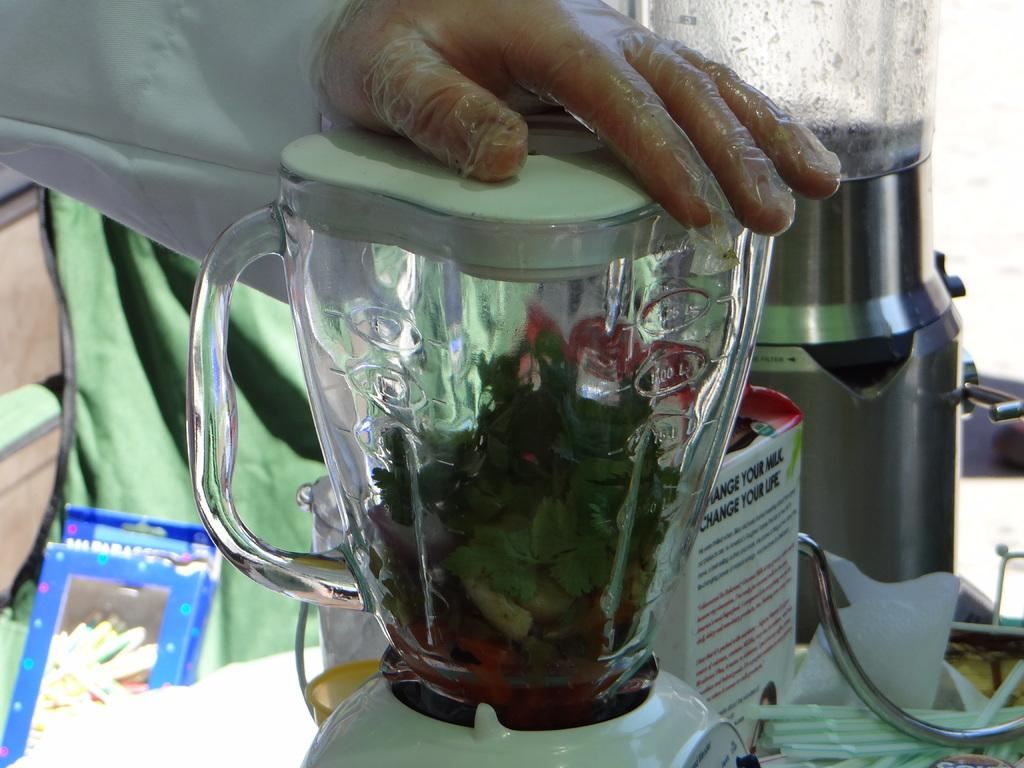<image>
Share a concise interpretation of the image provided. a sign on the back of an item that says change your life 